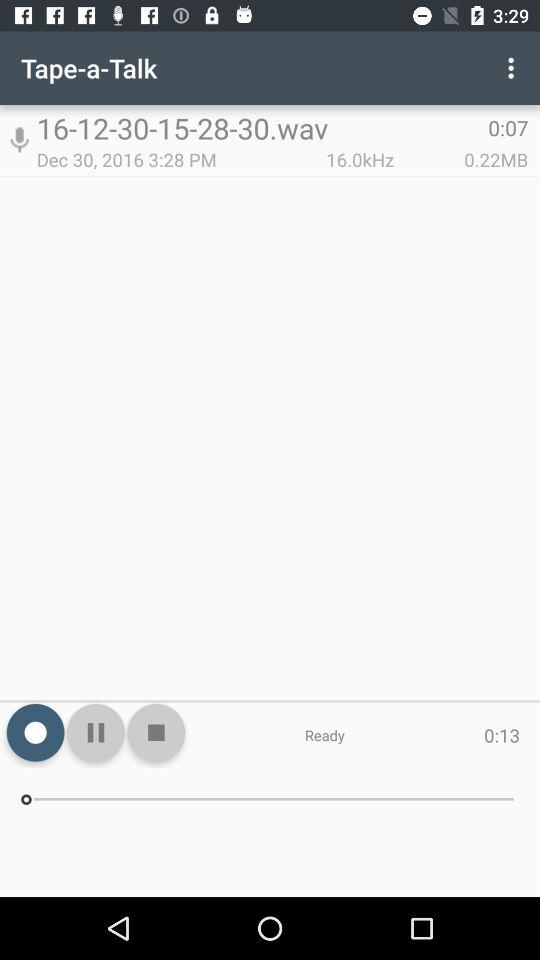What is the size of the audio "16-12-30-15-28-30.wav"? The size of the audio is 0.22 MB. 